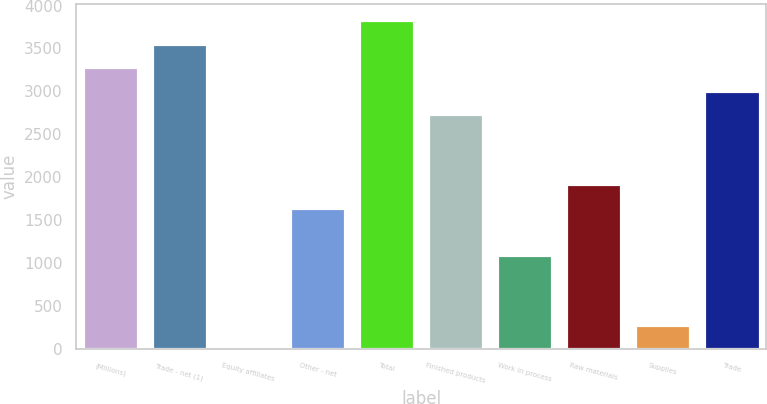Convert chart to OTSL. <chart><loc_0><loc_0><loc_500><loc_500><bar_chart><fcel>(Millions)<fcel>Trade - net (1)<fcel>Equity affiliates<fcel>Other - net<fcel>Total<fcel>Finished products<fcel>Work in process<fcel>Raw materials<fcel>Supplies<fcel>Trade<nl><fcel>3281.2<fcel>3553.8<fcel>10<fcel>1645.6<fcel>3826.4<fcel>2736<fcel>1100.4<fcel>1918.2<fcel>282.6<fcel>3008.6<nl></chart> 